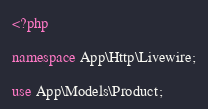<code> <loc_0><loc_0><loc_500><loc_500><_PHP_><?php

namespace App\Http\Livewire;

use App\Models\Product;</code> 